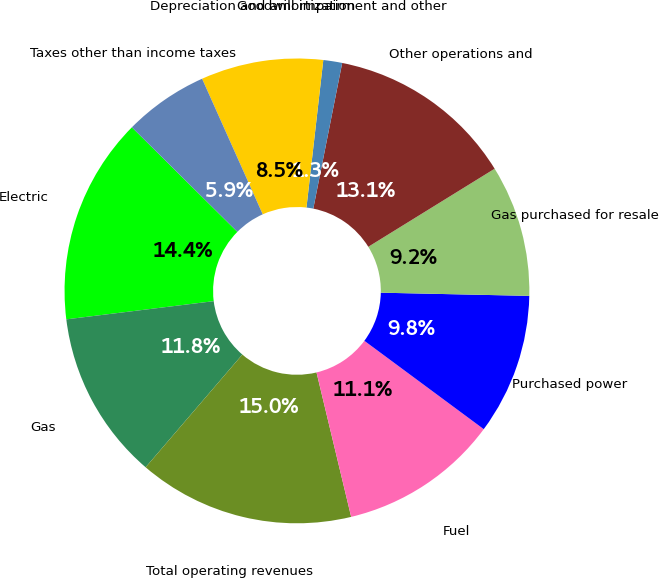Convert chart to OTSL. <chart><loc_0><loc_0><loc_500><loc_500><pie_chart><fcel>Electric<fcel>Gas<fcel>Total operating revenues<fcel>Fuel<fcel>Purchased power<fcel>Gas purchased for resale<fcel>Other operations and<fcel>Goodwill impairment and other<fcel>Depreciation and amortization<fcel>Taxes other than income taxes<nl><fcel>14.38%<fcel>11.76%<fcel>15.03%<fcel>11.11%<fcel>9.8%<fcel>9.15%<fcel>13.07%<fcel>1.31%<fcel>8.5%<fcel>5.88%<nl></chart> 